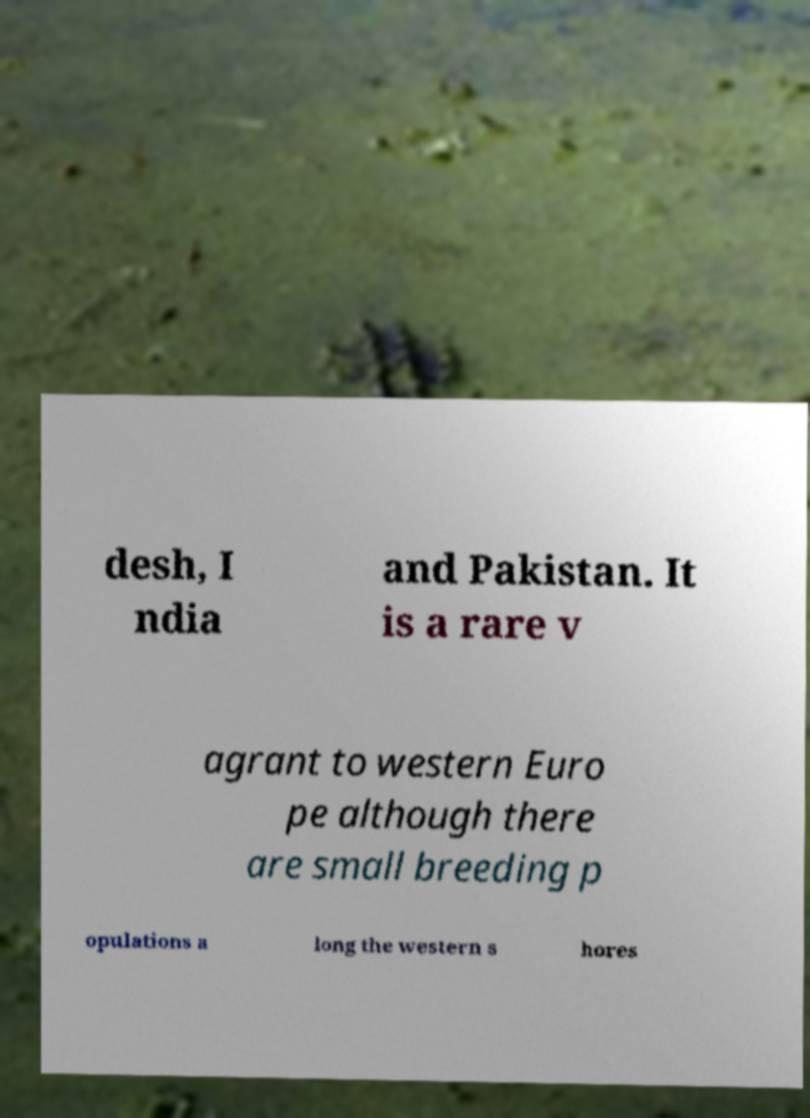For documentation purposes, I need the text within this image transcribed. Could you provide that? desh, I ndia and Pakistan. It is a rare v agrant to western Euro pe although there are small breeding p opulations a long the western s hores 